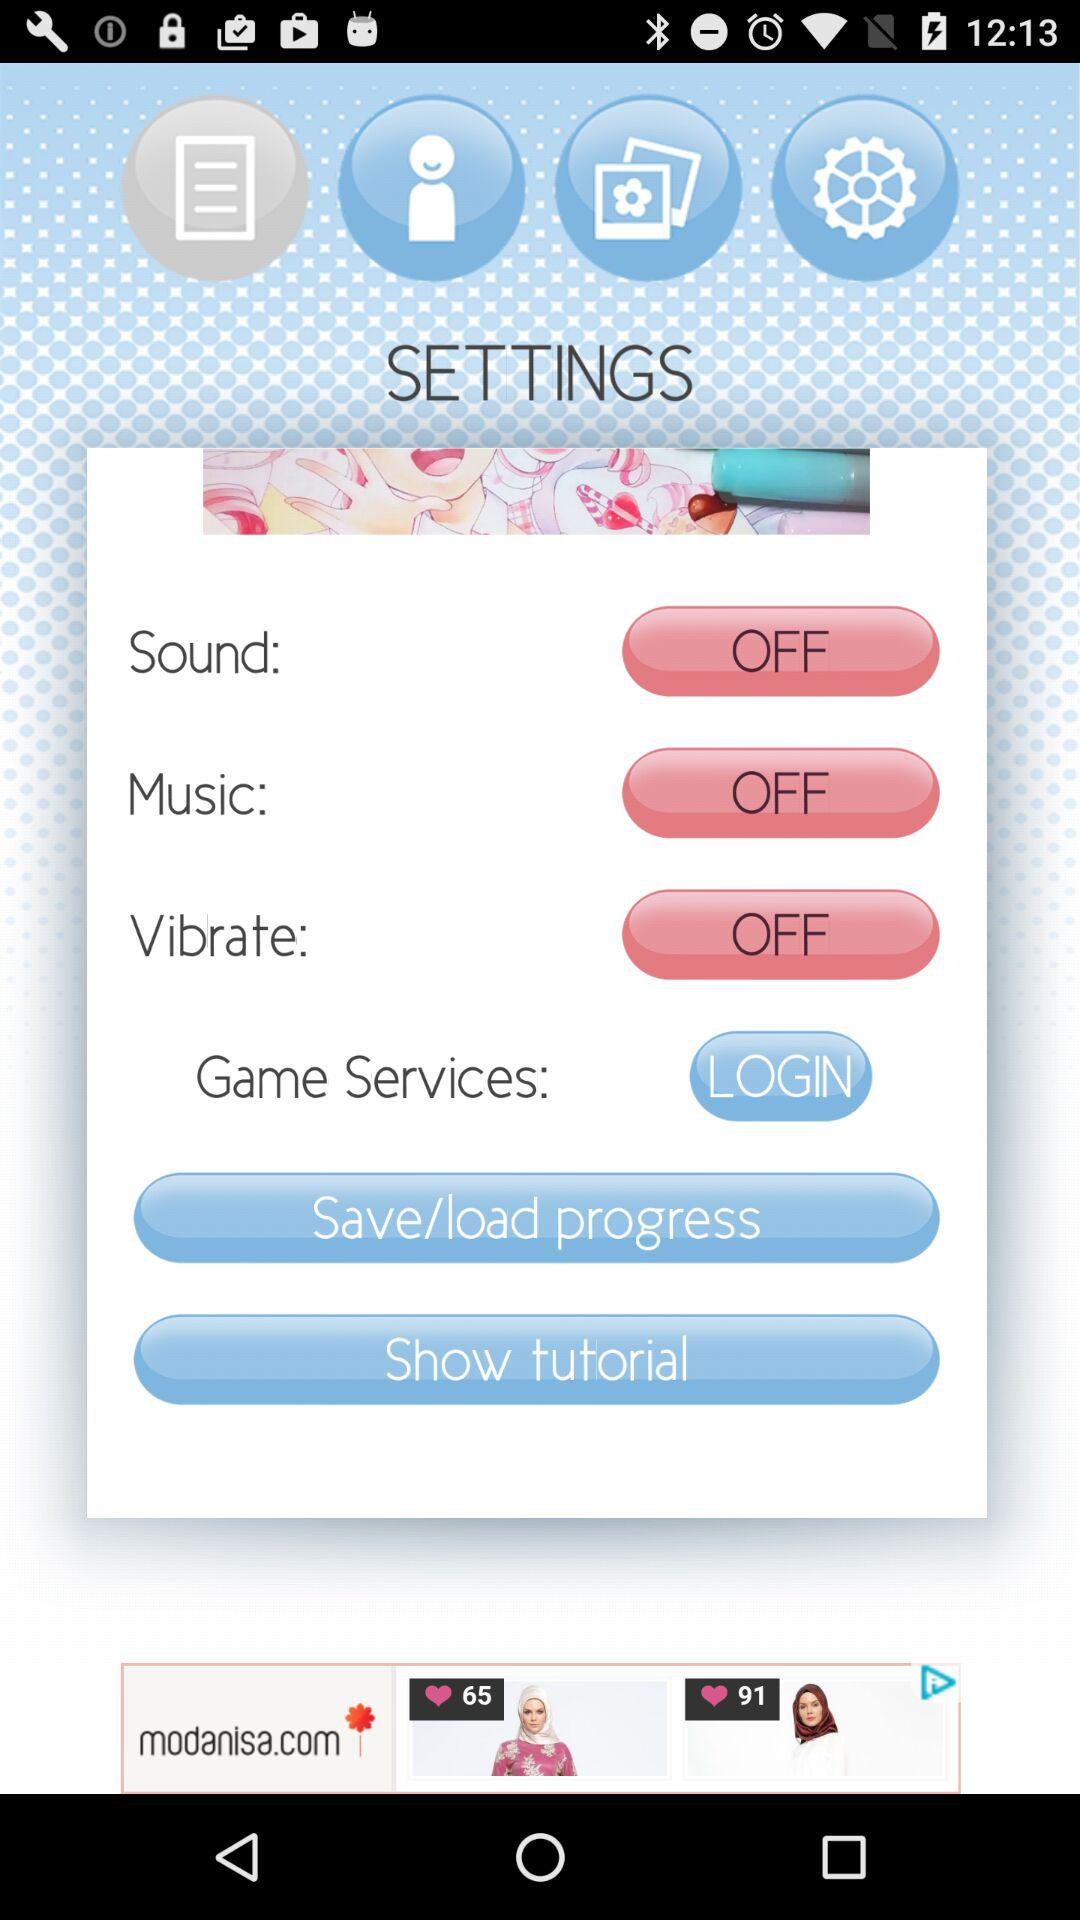How many settings are there in total?
Answer the question using a single word or phrase. 4 